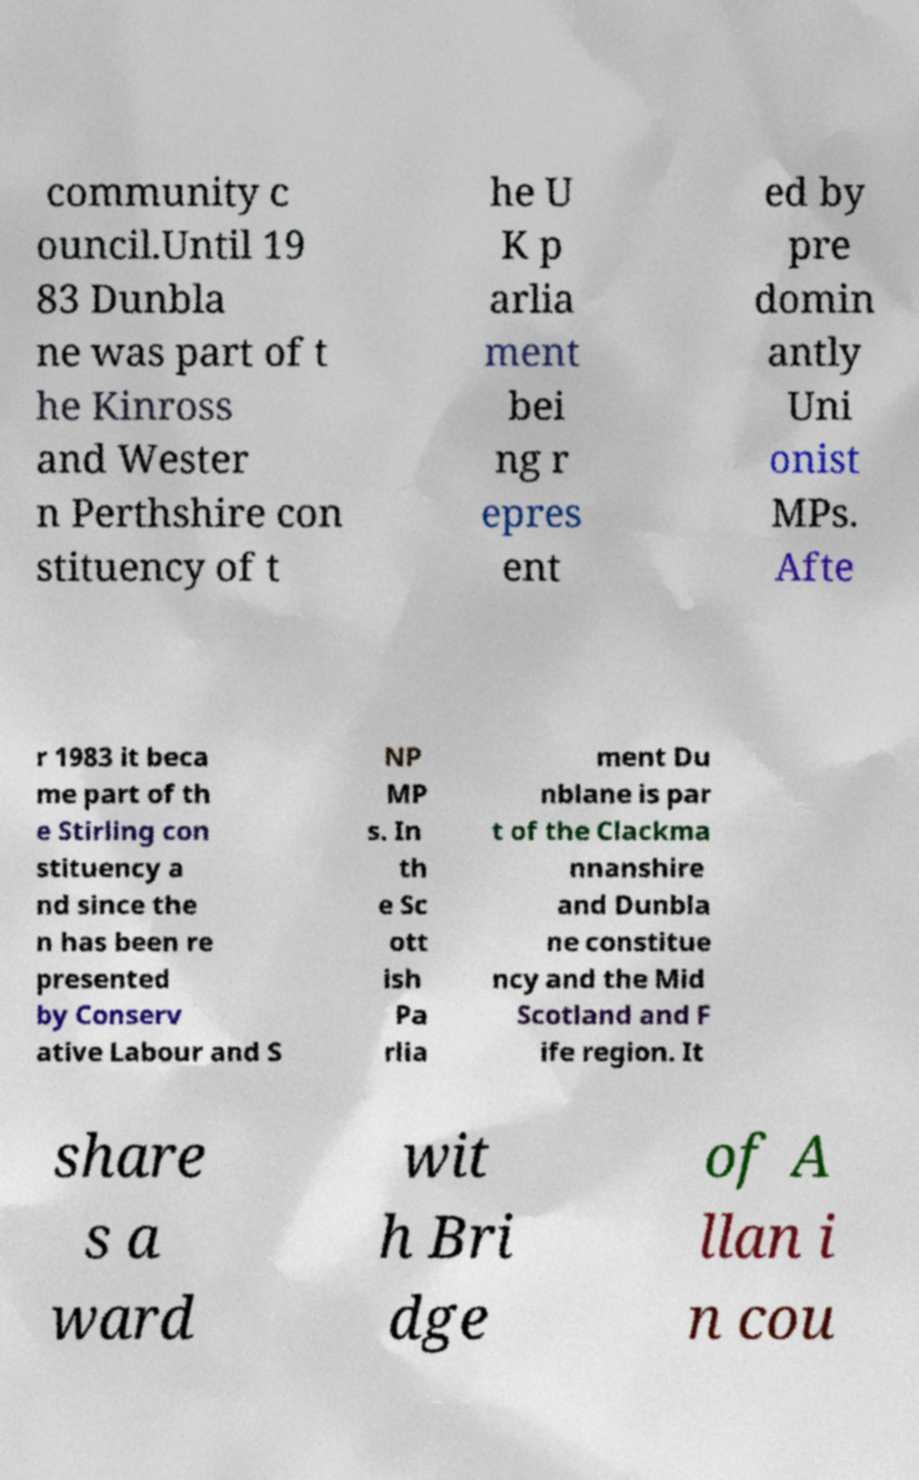For documentation purposes, I need the text within this image transcribed. Could you provide that? community c ouncil.Until 19 83 Dunbla ne was part of t he Kinross and Wester n Perthshire con stituency of t he U K p arlia ment bei ng r epres ent ed by pre domin antly Uni onist MPs. Afte r 1983 it beca me part of th e Stirling con stituency a nd since the n has been re presented by Conserv ative Labour and S NP MP s. In th e Sc ott ish Pa rlia ment Du nblane is par t of the Clackma nnanshire and Dunbla ne constitue ncy and the Mid Scotland and F ife region. It share s a ward wit h Bri dge of A llan i n cou 